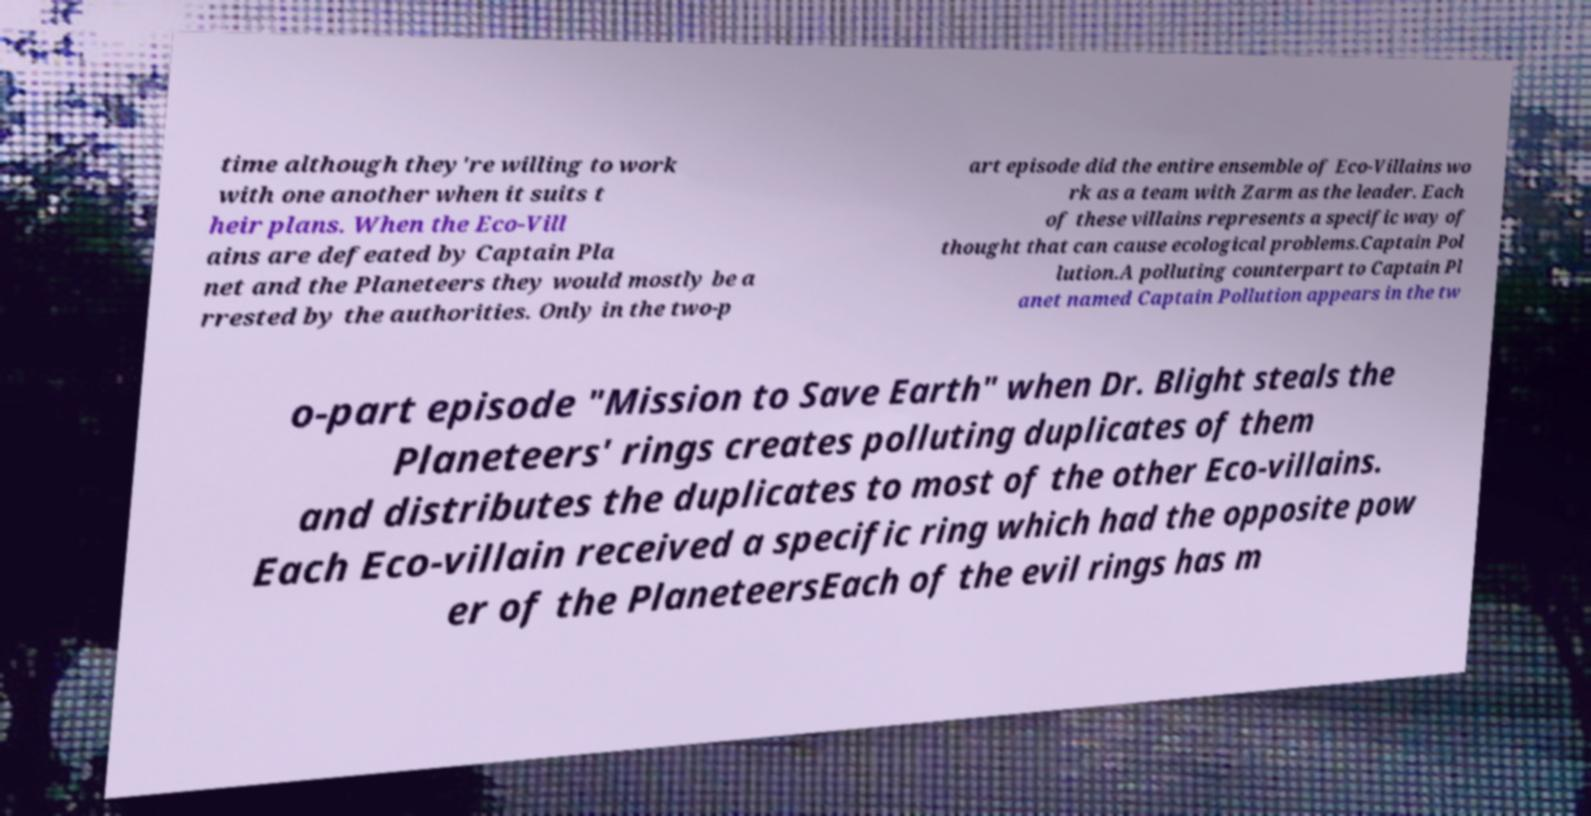I need the written content from this picture converted into text. Can you do that? time although they're willing to work with one another when it suits t heir plans. When the Eco-Vill ains are defeated by Captain Pla net and the Planeteers they would mostly be a rrested by the authorities. Only in the two-p art episode did the entire ensemble of Eco-Villains wo rk as a team with Zarm as the leader. Each of these villains represents a specific way of thought that can cause ecological problems.Captain Pol lution.A polluting counterpart to Captain Pl anet named Captain Pollution appears in the tw o-part episode "Mission to Save Earth" when Dr. Blight steals the Planeteers' rings creates polluting duplicates of them and distributes the duplicates to most of the other Eco-villains. Each Eco-villain received a specific ring which had the opposite pow er of the PlaneteersEach of the evil rings has m 